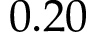Convert formula to latex. <formula><loc_0><loc_0><loc_500><loc_500>0 . 2 0</formula> 